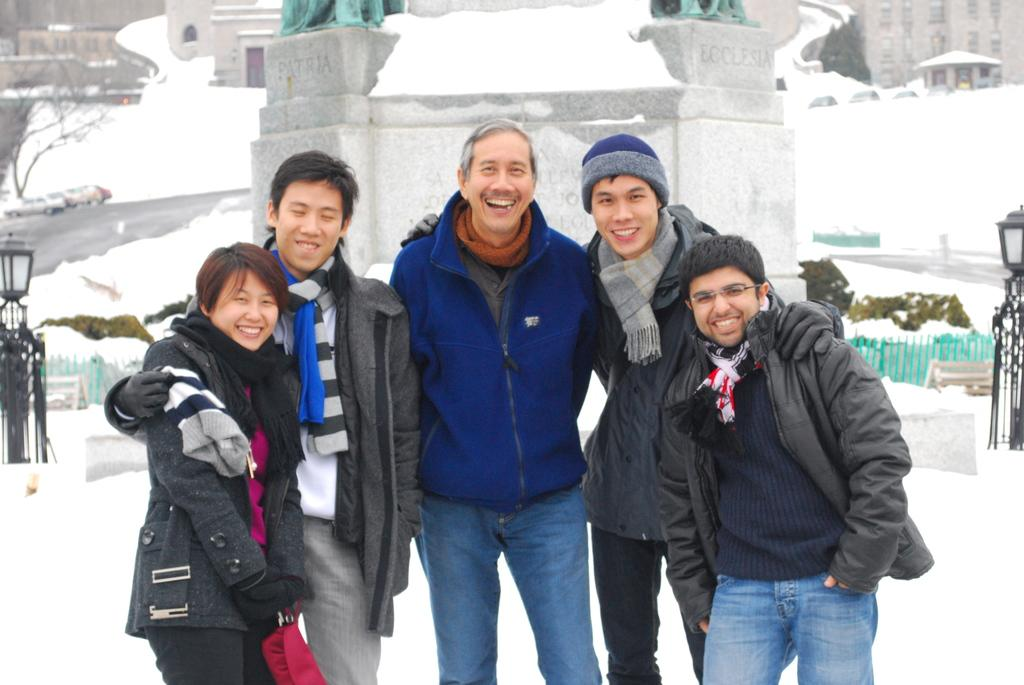What are the people in the image doing? The people in the image are standing and smiling. What can be seen in the background of the image? There are buildings, trees, and lights in the background of the image. What is present in the image that separates the foreground from the background? There is a fence in the image. What is the ground condition at the bottom of the image? There is snow at the bottom of the image. What type of minister is present in the image? There is no minister present in the image. Can you describe the group dynamics of the people in the image? The image only shows individuals standing and smiling, so it is not possible to describe group dynamics. 